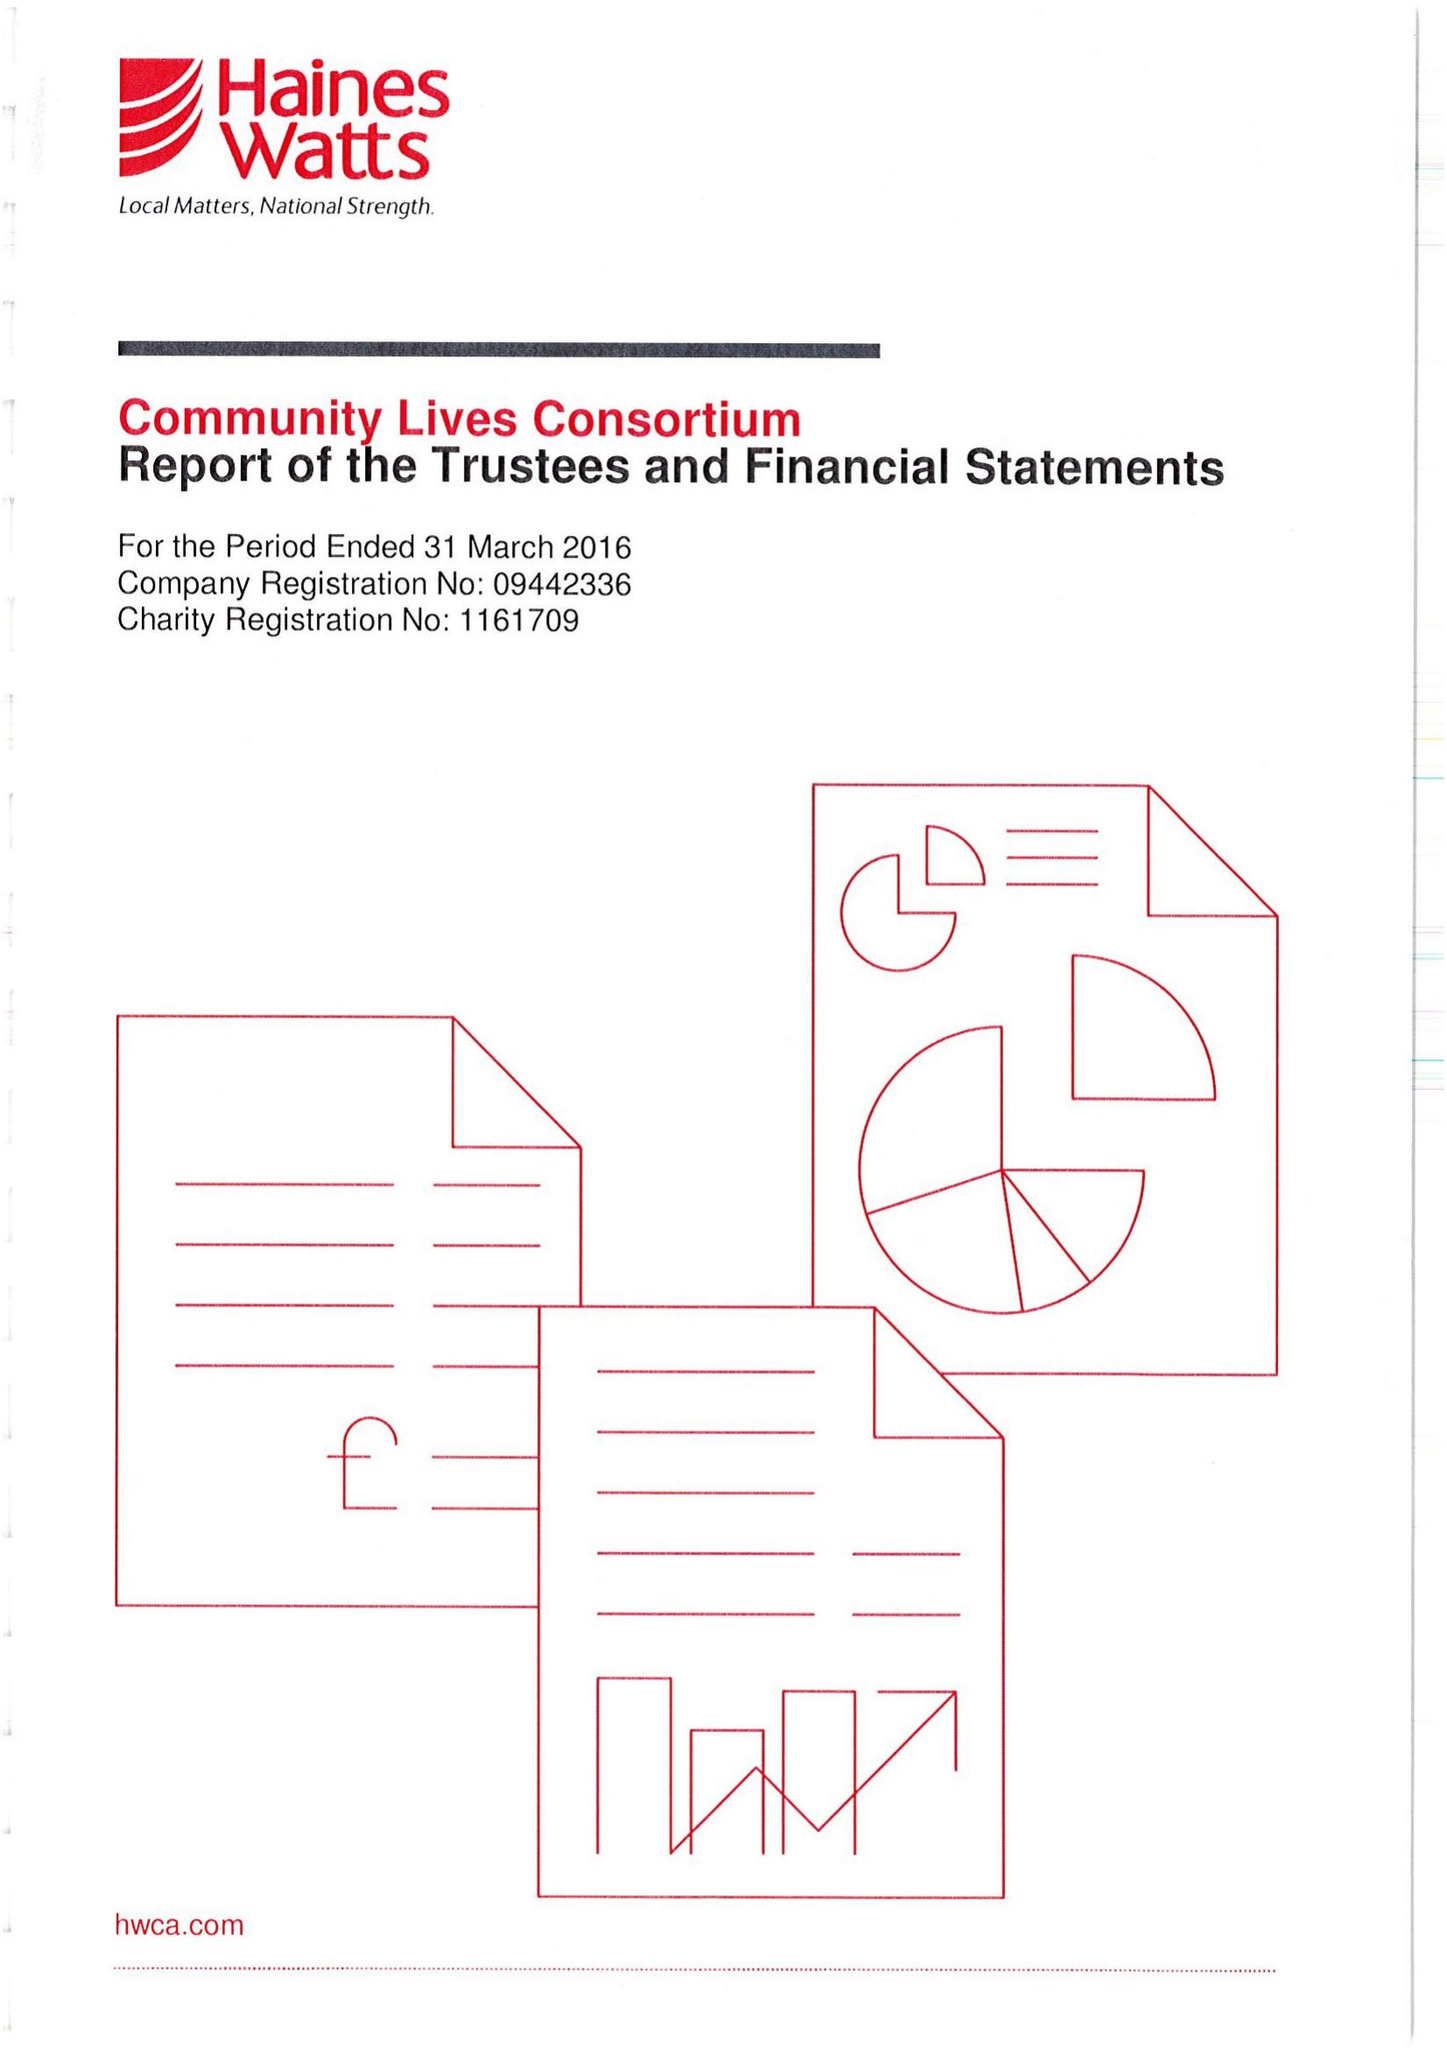What is the value for the spending_annually_in_british_pounds?
Answer the question using a single word or phrase. 17362635.00 